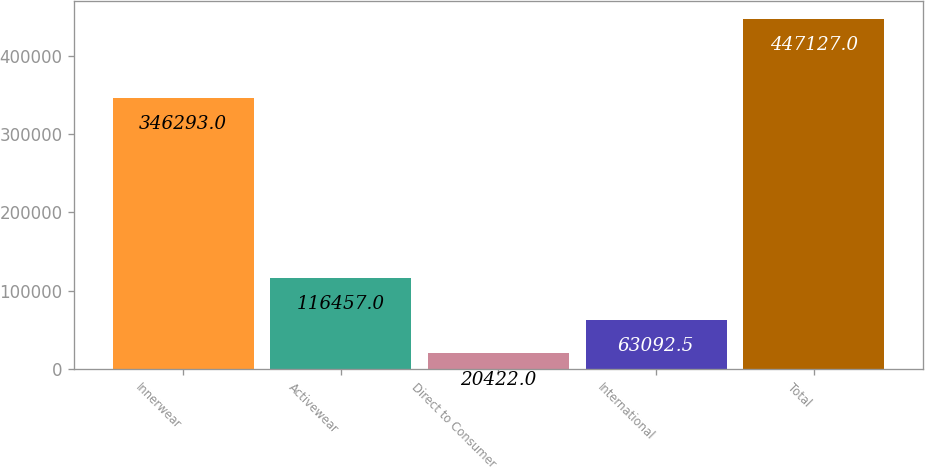<chart> <loc_0><loc_0><loc_500><loc_500><bar_chart><fcel>Innerwear<fcel>Activewear<fcel>Direct to Consumer<fcel>International<fcel>Total<nl><fcel>346293<fcel>116457<fcel>20422<fcel>63092.5<fcel>447127<nl></chart> 